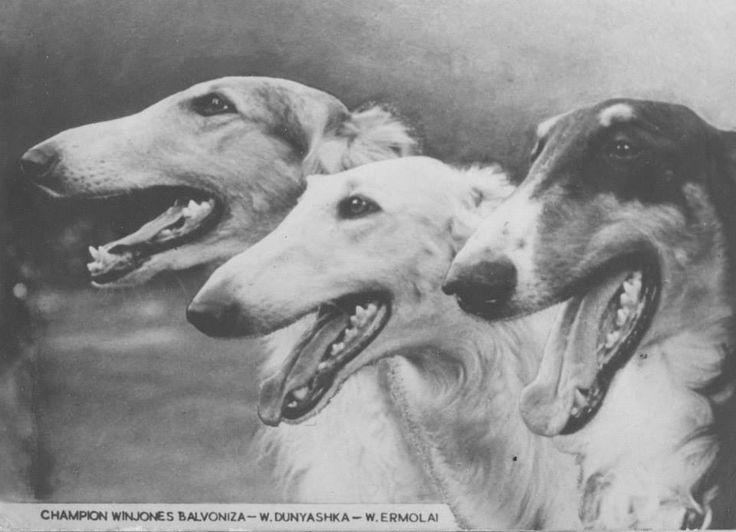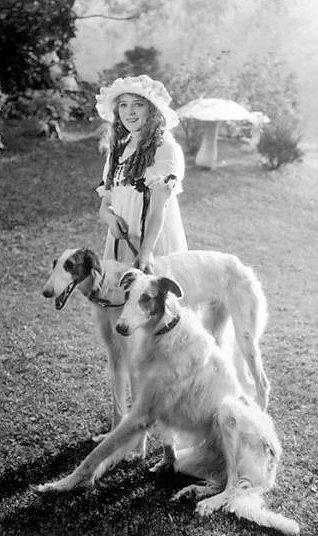The first image is the image on the left, the second image is the image on the right. Assess this claim about the two images: "There are only two dogs.". Correct or not? Answer yes or no. No. 